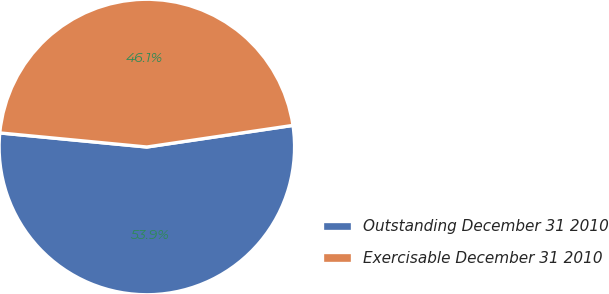Convert chart to OTSL. <chart><loc_0><loc_0><loc_500><loc_500><pie_chart><fcel>Outstanding December 31 2010<fcel>Exercisable December 31 2010<nl><fcel>53.86%<fcel>46.14%<nl></chart> 